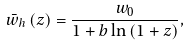Convert formula to latex. <formula><loc_0><loc_0><loc_500><loc_500>\bar { w } _ { h } \left ( z \right ) = \frac { w _ { 0 } } { 1 + b \ln \left ( 1 + z \right ) } ,</formula> 